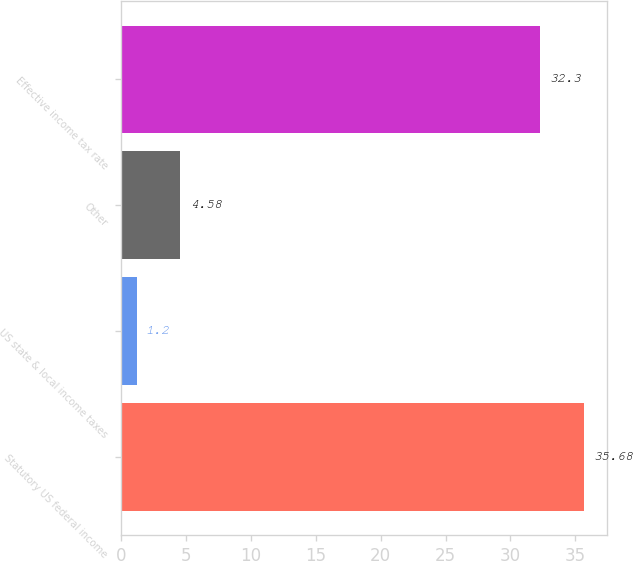Convert chart to OTSL. <chart><loc_0><loc_0><loc_500><loc_500><bar_chart><fcel>Statutory US federal income<fcel>US state & local income taxes<fcel>Other<fcel>Effective income tax rate<nl><fcel>35.68<fcel>1.2<fcel>4.58<fcel>32.3<nl></chart> 